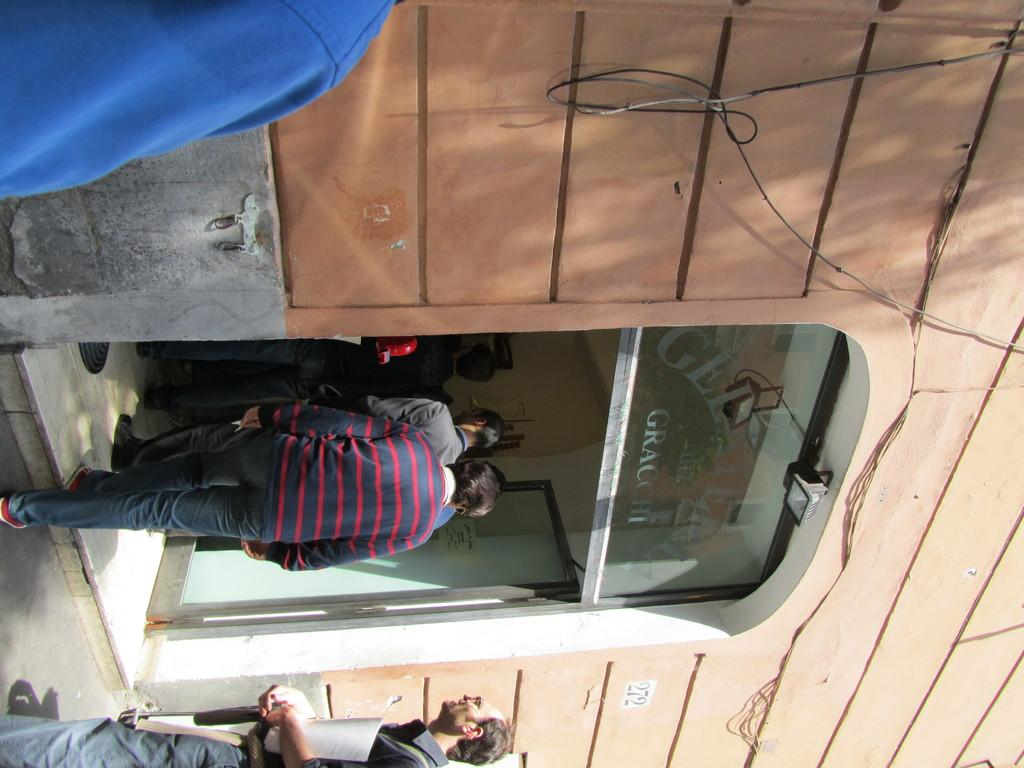What type of structure is present in the image? There is a building in the image. Can you describe any specific features of the building? There is a door visible in the image. Are there any living beings present in the image? Yes, there are people visible in the image. What else can be seen in the image besides the building and people? There are wires present in the image. What type of fruit is hanging from the elbow of the person in the image? There is no fruit or elbow visible in the image; it only features a building, a door, people, and wires. 